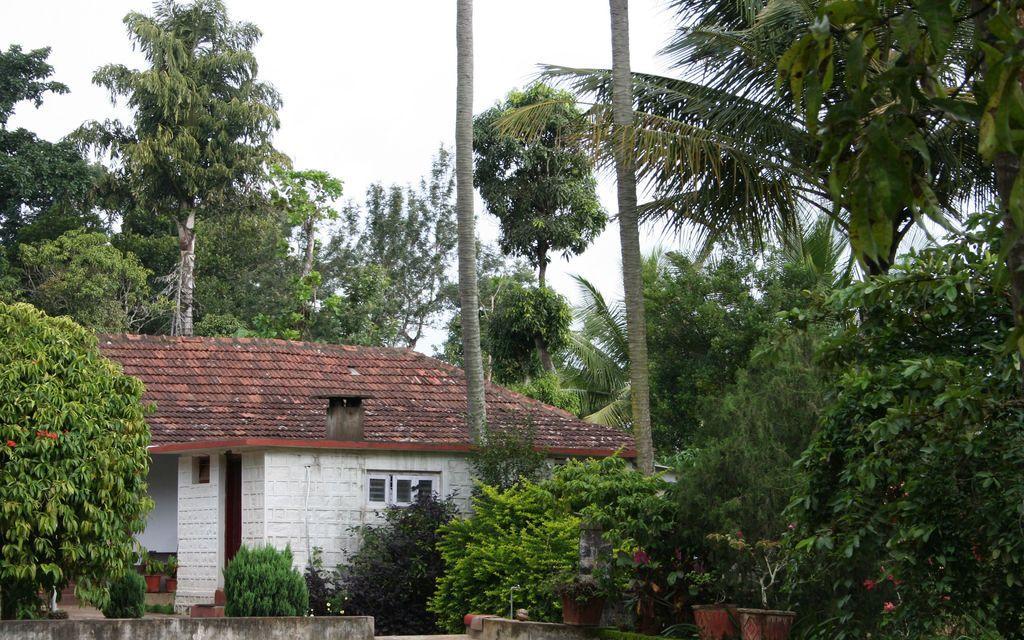Could you give a brief overview of what you see in this image? In this picture I can observe house in the middle of the picture. In front of the house I can observe plants. In the background there are trees and sky. 